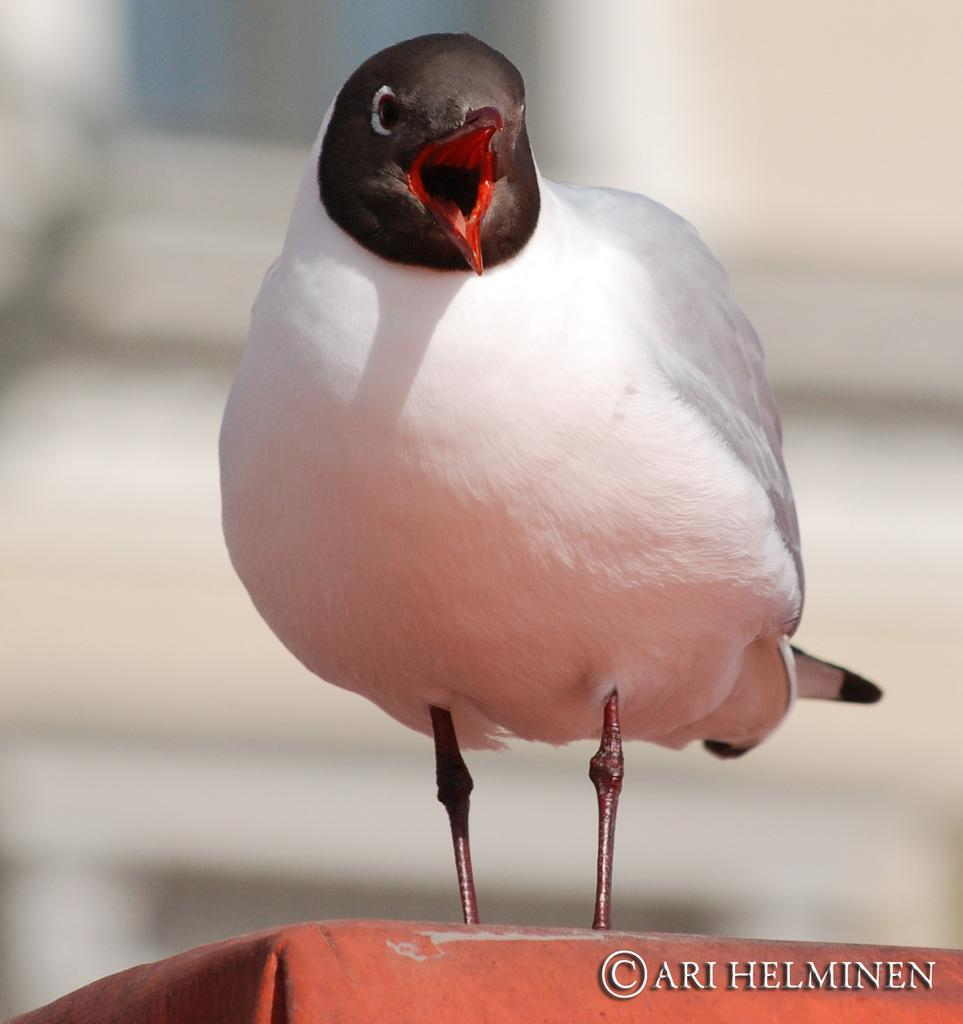What type of animal is in the image? There is a bird in the image. Can you describe the bird's coloring? The bird has white and brown colors. What is the bird standing on in the image? The bird is on an orange surface. How would you describe the background of the image? The background of the image is blurred. What type of wine is being served in the afternoon in the image? There is no wine or indication of a specific time of day in the image; it features a bird on an orange surface with a blurred background. 